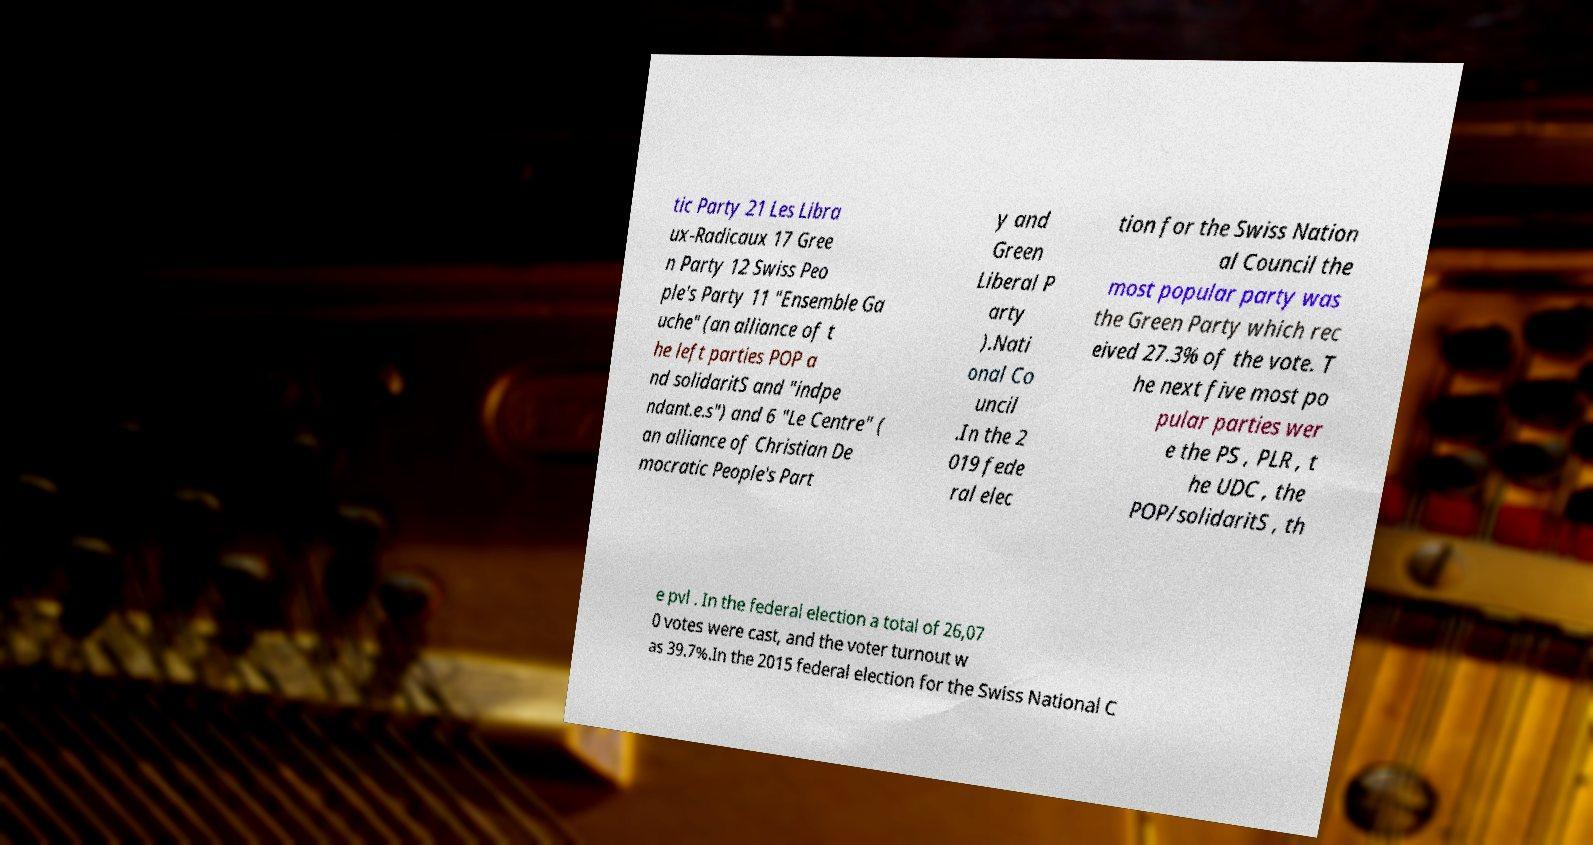Could you extract and type out the text from this image? tic Party 21 Les Libra ux-Radicaux 17 Gree n Party 12 Swiss Peo ple's Party 11 "Ensemble Ga uche" (an alliance of t he left parties POP a nd solidaritS and "indpe ndant.e.s") and 6 "Le Centre" ( an alliance of Christian De mocratic People's Part y and Green Liberal P arty ).Nati onal Co uncil .In the 2 019 fede ral elec tion for the Swiss Nation al Council the most popular party was the Green Party which rec eived 27.3% of the vote. T he next five most po pular parties wer e the PS , PLR , t he UDC , the POP/solidaritS , th e pvl . In the federal election a total of 26,07 0 votes were cast, and the voter turnout w as 39.7%.In the 2015 federal election for the Swiss National C 